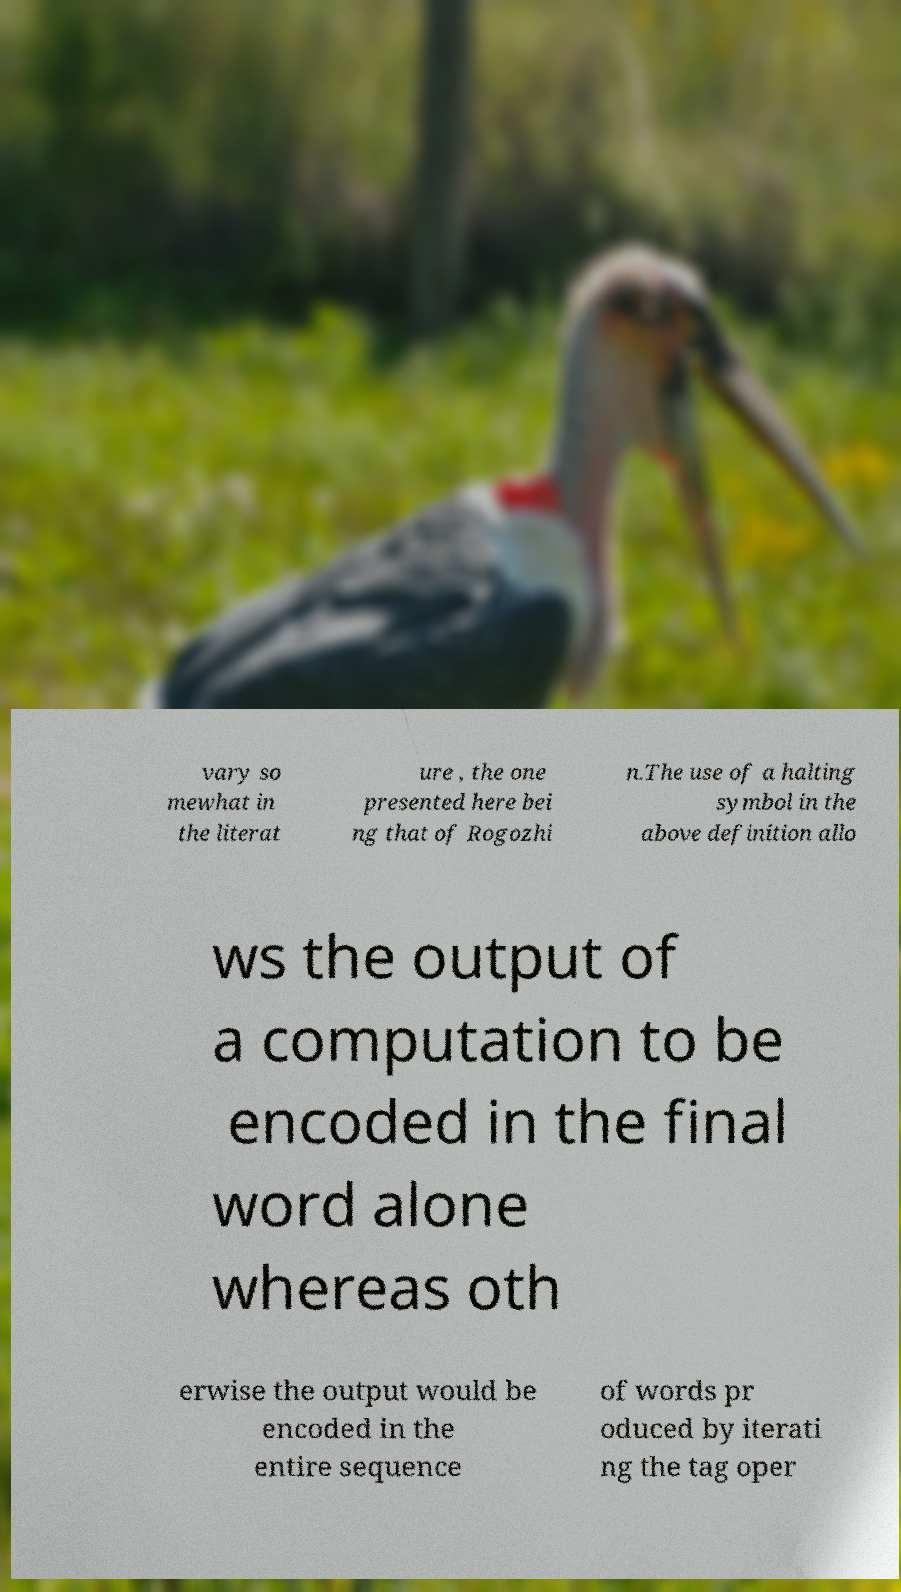Please read and relay the text visible in this image. What does it say? vary so mewhat in the literat ure , the one presented here bei ng that of Rogozhi n.The use of a halting symbol in the above definition allo ws the output of a computation to be encoded in the final word alone whereas oth erwise the output would be encoded in the entire sequence of words pr oduced by iterati ng the tag oper 